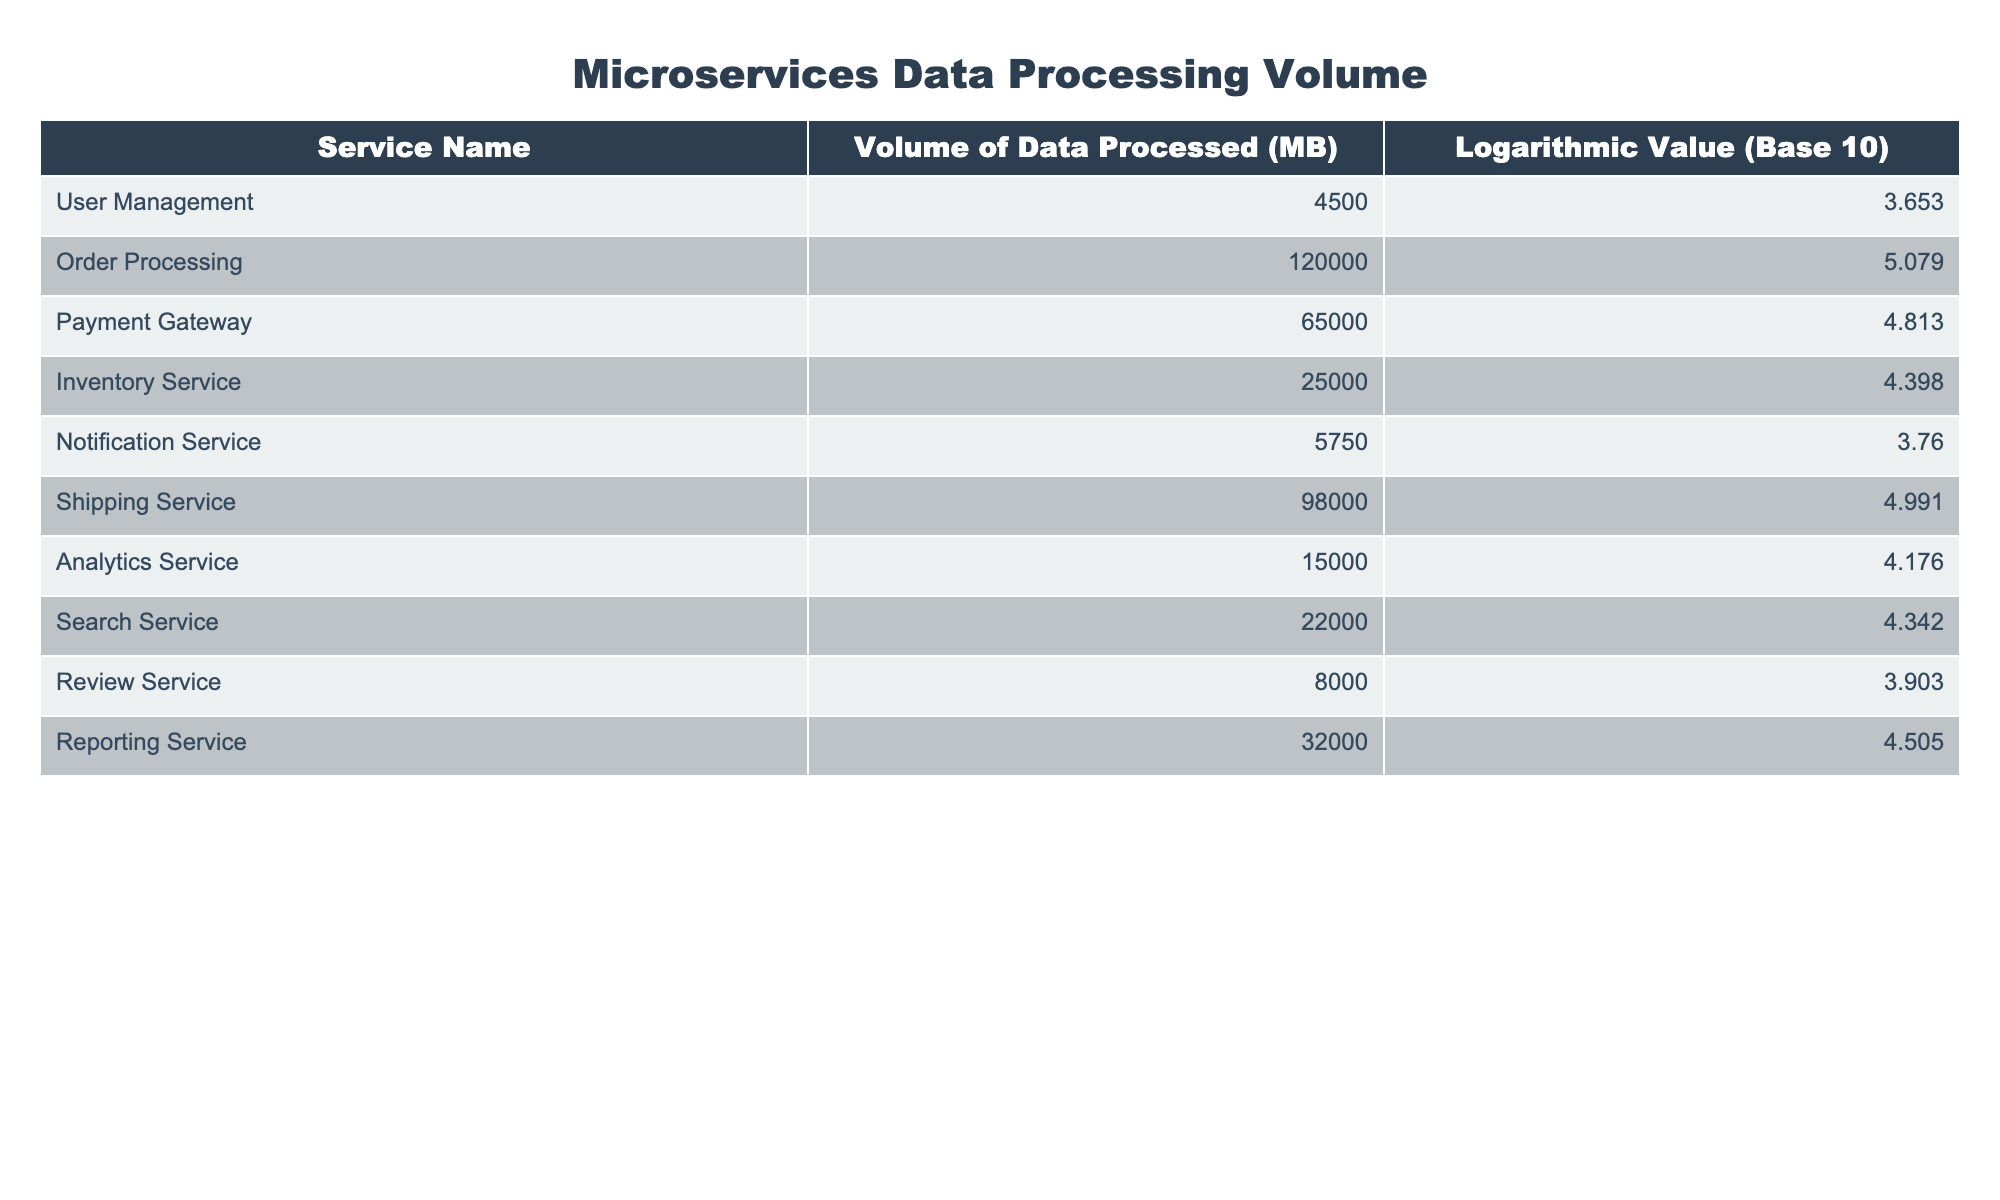What is the volume of data processed by the User Management service? The table shows that the volume of data processed by the User Management service is 4500 MB, as listed directly in the "Volume of Data Processed (MB)" column.
Answer: 4500 MB Which microservice processed the highest volume of data? From the "Volume of Data Processed (MB)" column, the Order Processing service shows the highest value at 120000 MB, indicating that it processed the most data compared to the other services.
Answer: Order Processing What is the difference in data volume between the Payment Gateway and the Shipping Service? The Payment Gateway processed 65000 MB, and the Shipping Service processed 98000 MB. The difference is calculated by subtracting the Payment Gateway's value from the Shipping Service's value: 98000 - 65000 = 33000 MB.
Answer: 33000 MB Is the volume of data processed by the Analytics Service greater than that of the Review Service? The Analytics Service processed 15000 MB and the Review Service processed 8000 MB. Since 15000 is greater than 8000, the statement is true.
Answer: Yes What is the average volume of data processed by all services listed? To find the average, sum the volumes: 4500 + 120000 + 65000 + 25000 + 5750 + 98000 + 15000 + 22000 + 8000 + 32000 = 330250 MB. There are 10 services, so the average is 330250 / 10 = 33025 MB.
Answer: 33025 MB Which microservices have a logarithmic value greater than 4.5? Checking the "Logarithmic Value (Base 10)" column, the services with values greater than 4.5 are: Order Processing (5.079), Payment Gateway (4.813), Shipping Service (4.991), and Reporting Service (4.505).
Answer: Order Processing, Payment Gateway, Shipping Service, Reporting Service What is the total volume of data processed by the services that start with the letter "S"? The services that start with "S" are Shipping Service (98000 MB) and Search Service (22000 MB). The total is 98000 + 22000 = 120000 MB.
Answer: 120000 MB Is the volume of data processed by the Notification Service more than twice that of the Review Service? The Notification Service processed 5750 MB and the Review Service processed 8000 MB. Twice the Review Service's volume is 2 * 8000 = 16000 MB. Since 5750 is less than 16000, the statement is false.
Answer: No How many services processed more than 25000 MB of data? By reviewing the "Volume of Data Processed (MB)" column, the services that processed more than 25000 MB are: Order Processing, Payment Gateway, Shipping Service, and Reporting Service. There are 4 such services.
Answer: 4 